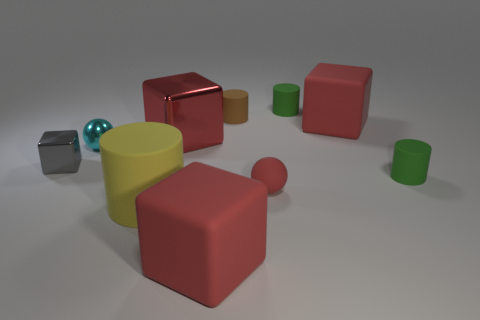What size is the shiny cube that is the same color as the tiny matte sphere?
Provide a short and direct response. Large. Is there a big red block that has the same material as the tiny gray cube?
Your response must be concise. Yes. Are there an equal number of rubber blocks that are to the right of the big yellow rubber cylinder and tiny green rubber cylinders right of the large shiny block?
Your answer should be very brief. Yes. How big is the red cube in front of the big yellow cylinder?
Offer a terse response. Large. The large red thing in front of the tiny green thing in front of the cyan shiny thing is made of what material?
Provide a short and direct response. Rubber. There is a big rubber cube on the right side of the large matte object in front of the large yellow matte thing; what number of red metal cubes are to the left of it?
Keep it short and to the point. 1. Is the material of the red block in front of the cyan thing the same as the tiny sphere that is on the left side of the yellow thing?
Offer a terse response. No. There is a small thing that is the same color as the large metal block; what is it made of?
Offer a very short reply. Rubber. What number of other shiny objects have the same shape as the tiny gray thing?
Offer a terse response. 1. Is the number of small green cylinders in front of the yellow object greater than the number of small brown rubber cylinders?
Provide a succinct answer. No. 